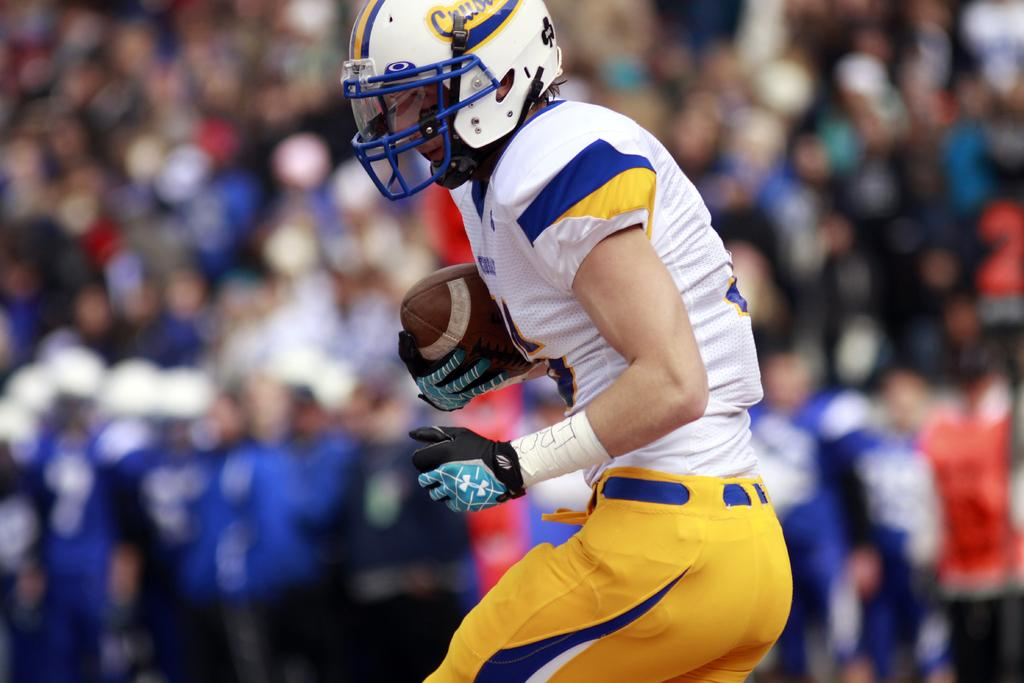What is the main subject of the image? There is a person in the image. What type of clothing is the person wearing? The person is wearing a sports uniform. What protective gear is the person wearing? The person is wearing a helmet. What object is the person holding? The person is holding a rugby ball. How would you describe the background of the image? The background of the image is blurry. Can you tell me how many goats are present in the image? There are no goats present in the image; it features a person wearing a sports uniform, a helmet, and holding a rugby ball. What type of event is taking place in the image? The image does not provide enough information to determine the type of event taking place, as it only shows a person wearing a sports uniform, a helmet, and holding a rugby ball. 